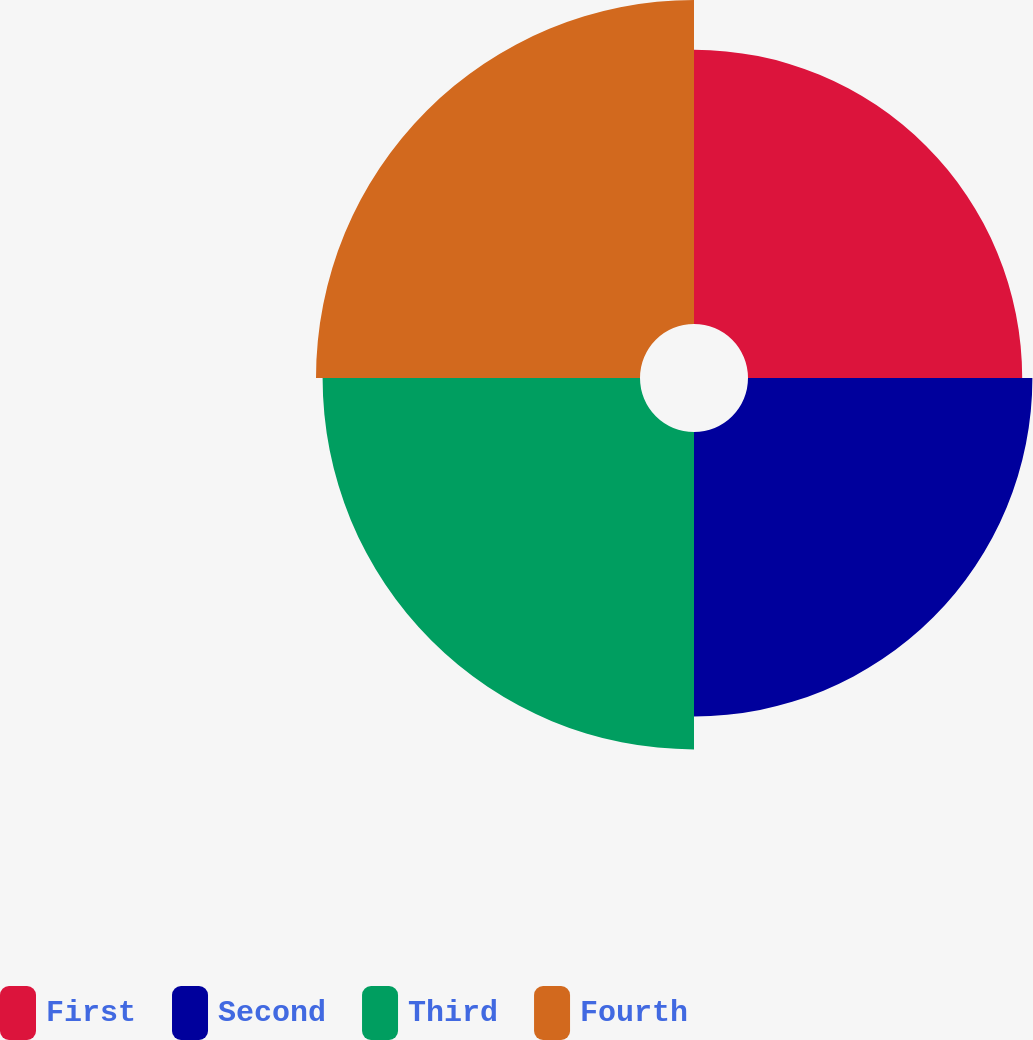Convert chart. <chart><loc_0><loc_0><loc_500><loc_500><pie_chart><fcel>First<fcel>Second<fcel>Third<fcel>Fourth<nl><fcel>22.85%<fcel>23.7%<fcel>26.45%<fcel>27.0%<nl></chart> 